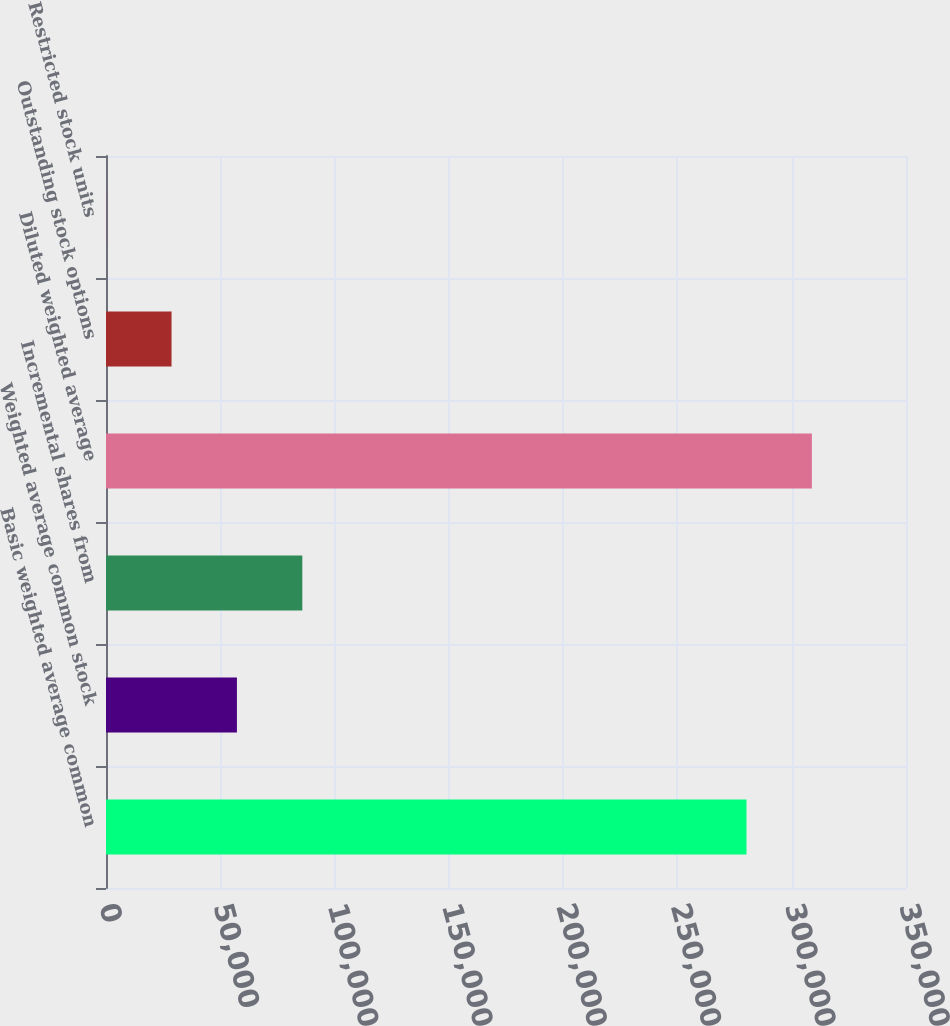<chart> <loc_0><loc_0><loc_500><loc_500><bar_chart><fcel>Basic weighted average common<fcel>Weighted average common stock<fcel>Incremental shares from<fcel>Diluted weighted average<fcel>Outstanding stock options<fcel>Restricted stock units<nl><fcel>280213<fcel>57280.8<fcel>85890.2<fcel>308822<fcel>28671.4<fcel>62<nl></chart> 